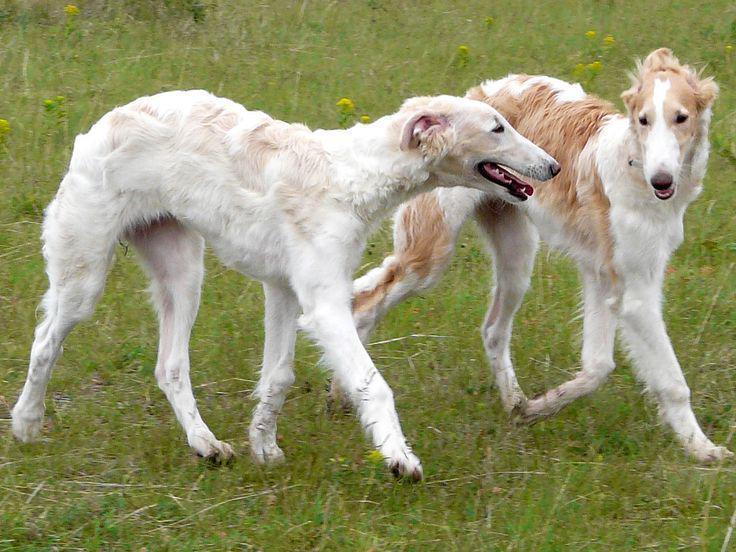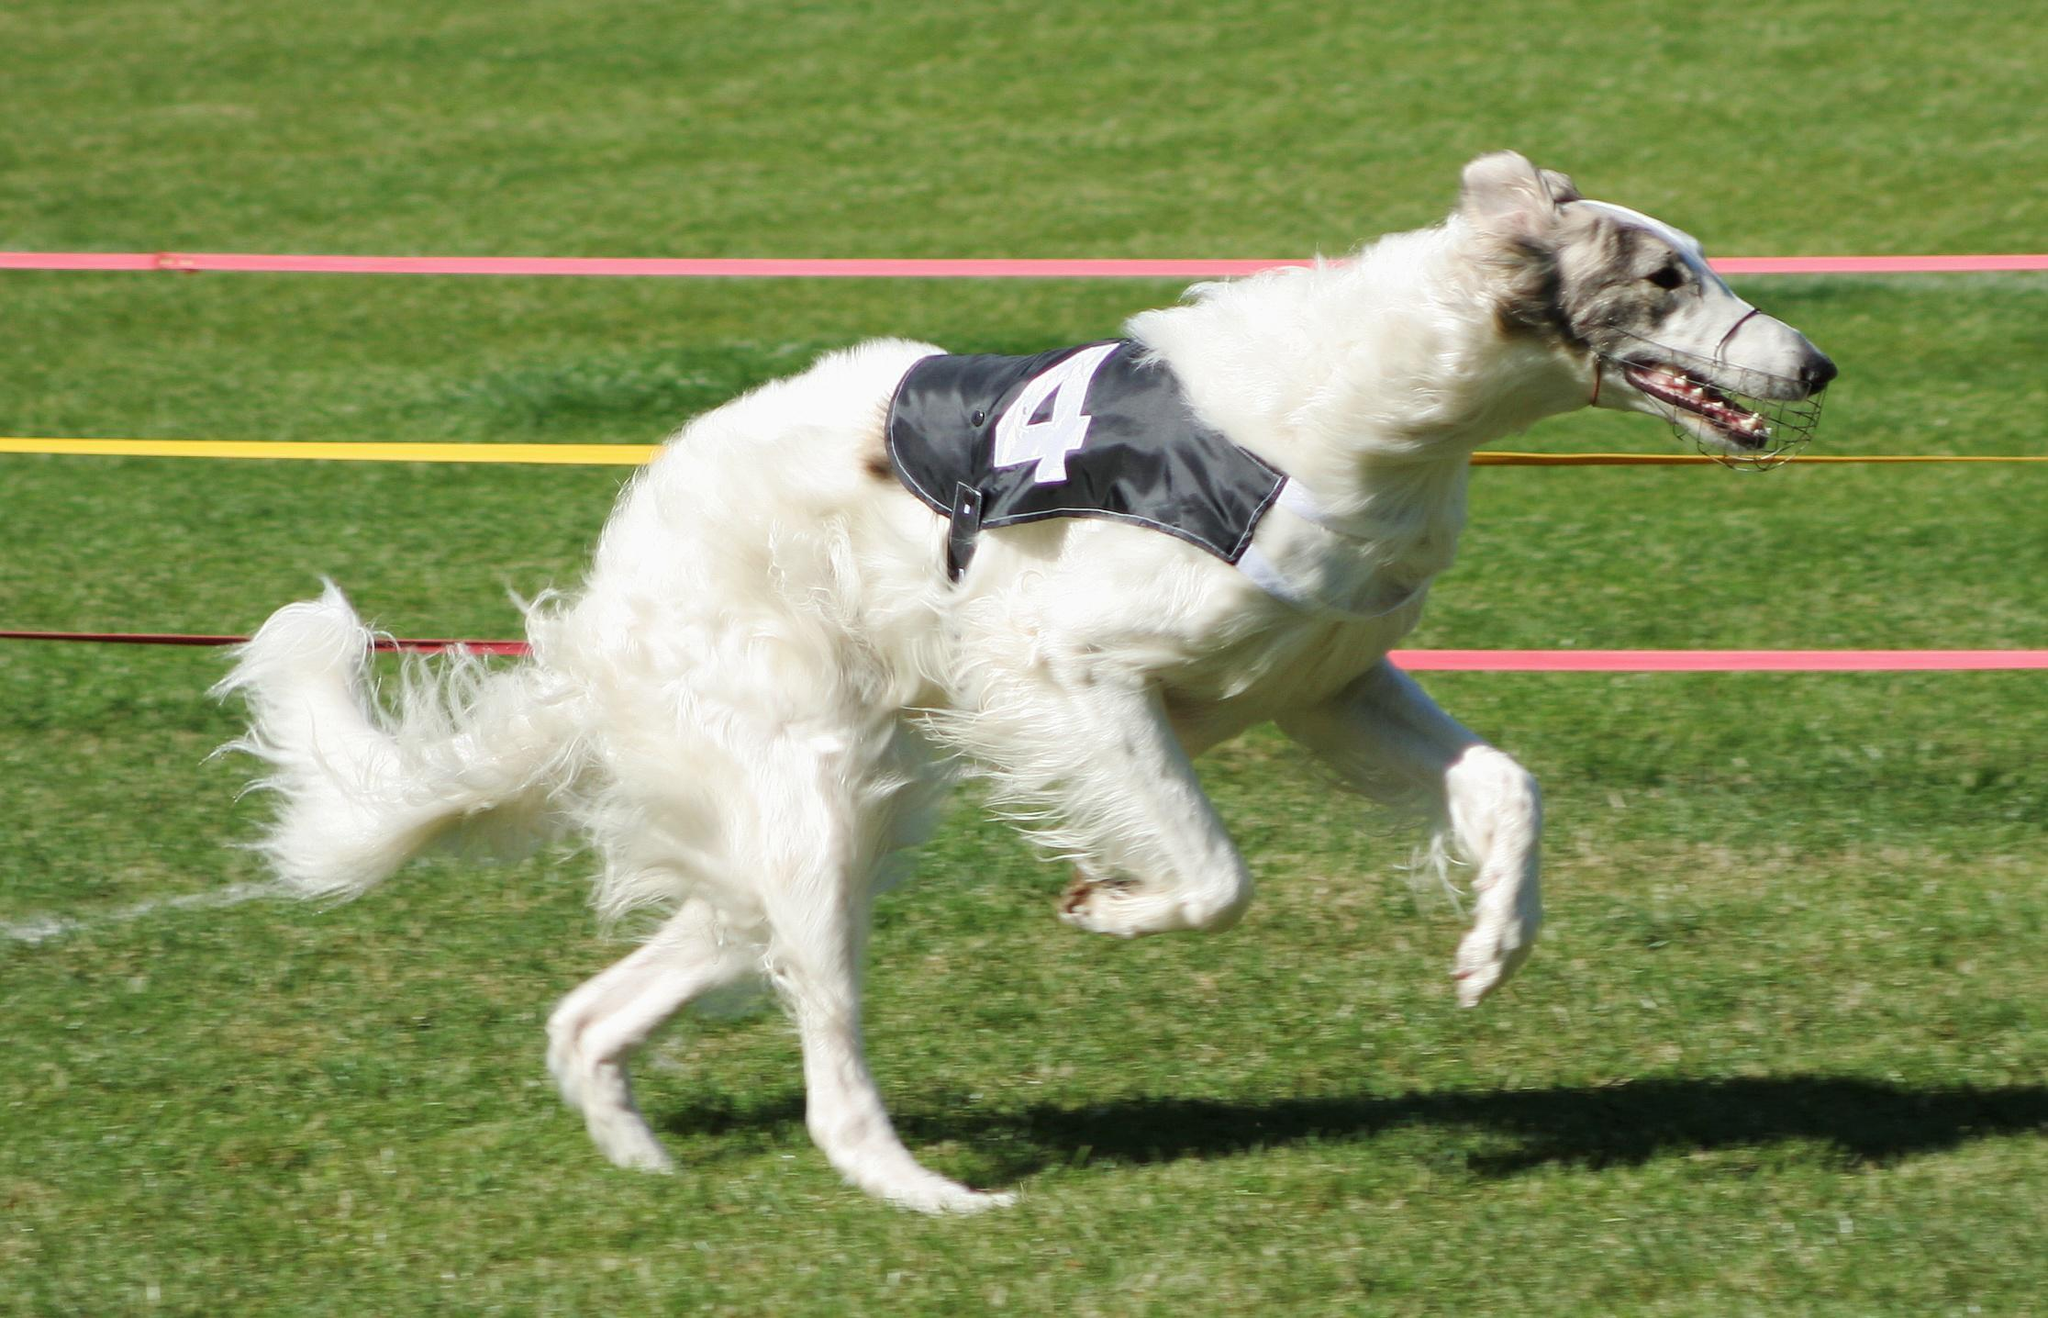The first image is the image on the left, the second image is the image on the right. Examine the images to the left and right. Is the description "One of the images contains exactly two dogs." accurate? Answer yes or no. Yes. 